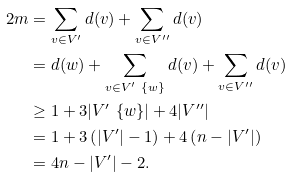Convert formula to latex. <formula><loc_0><loc_0><loc_500><loc_500>2 m & = \sum _ { v \in V ^ { \prime } } d ( v ) + \sum _ { v \in V ^ { \prime \prime } } d ( v ) \\ & = d ( w ) + \sum _ { v \in V ^ { \prime } \ \{ w \} } d ( v ) + \sum _ { v \in V ^ { \prime \prime } } d ( v ) \\ & \geq 1 + 3 | V ^ { \prime } \ \{ w \} | + 4 | V ^ { \prime \prime } | \\ & = 1 + 3 \left ( | V ^ { \prime } | - 1 \right ) + 4 \left ( n - | V ^ { \prime } | \right ) \\ & = 4 n - | V ^ { \prime } | - 2 .</formula> 